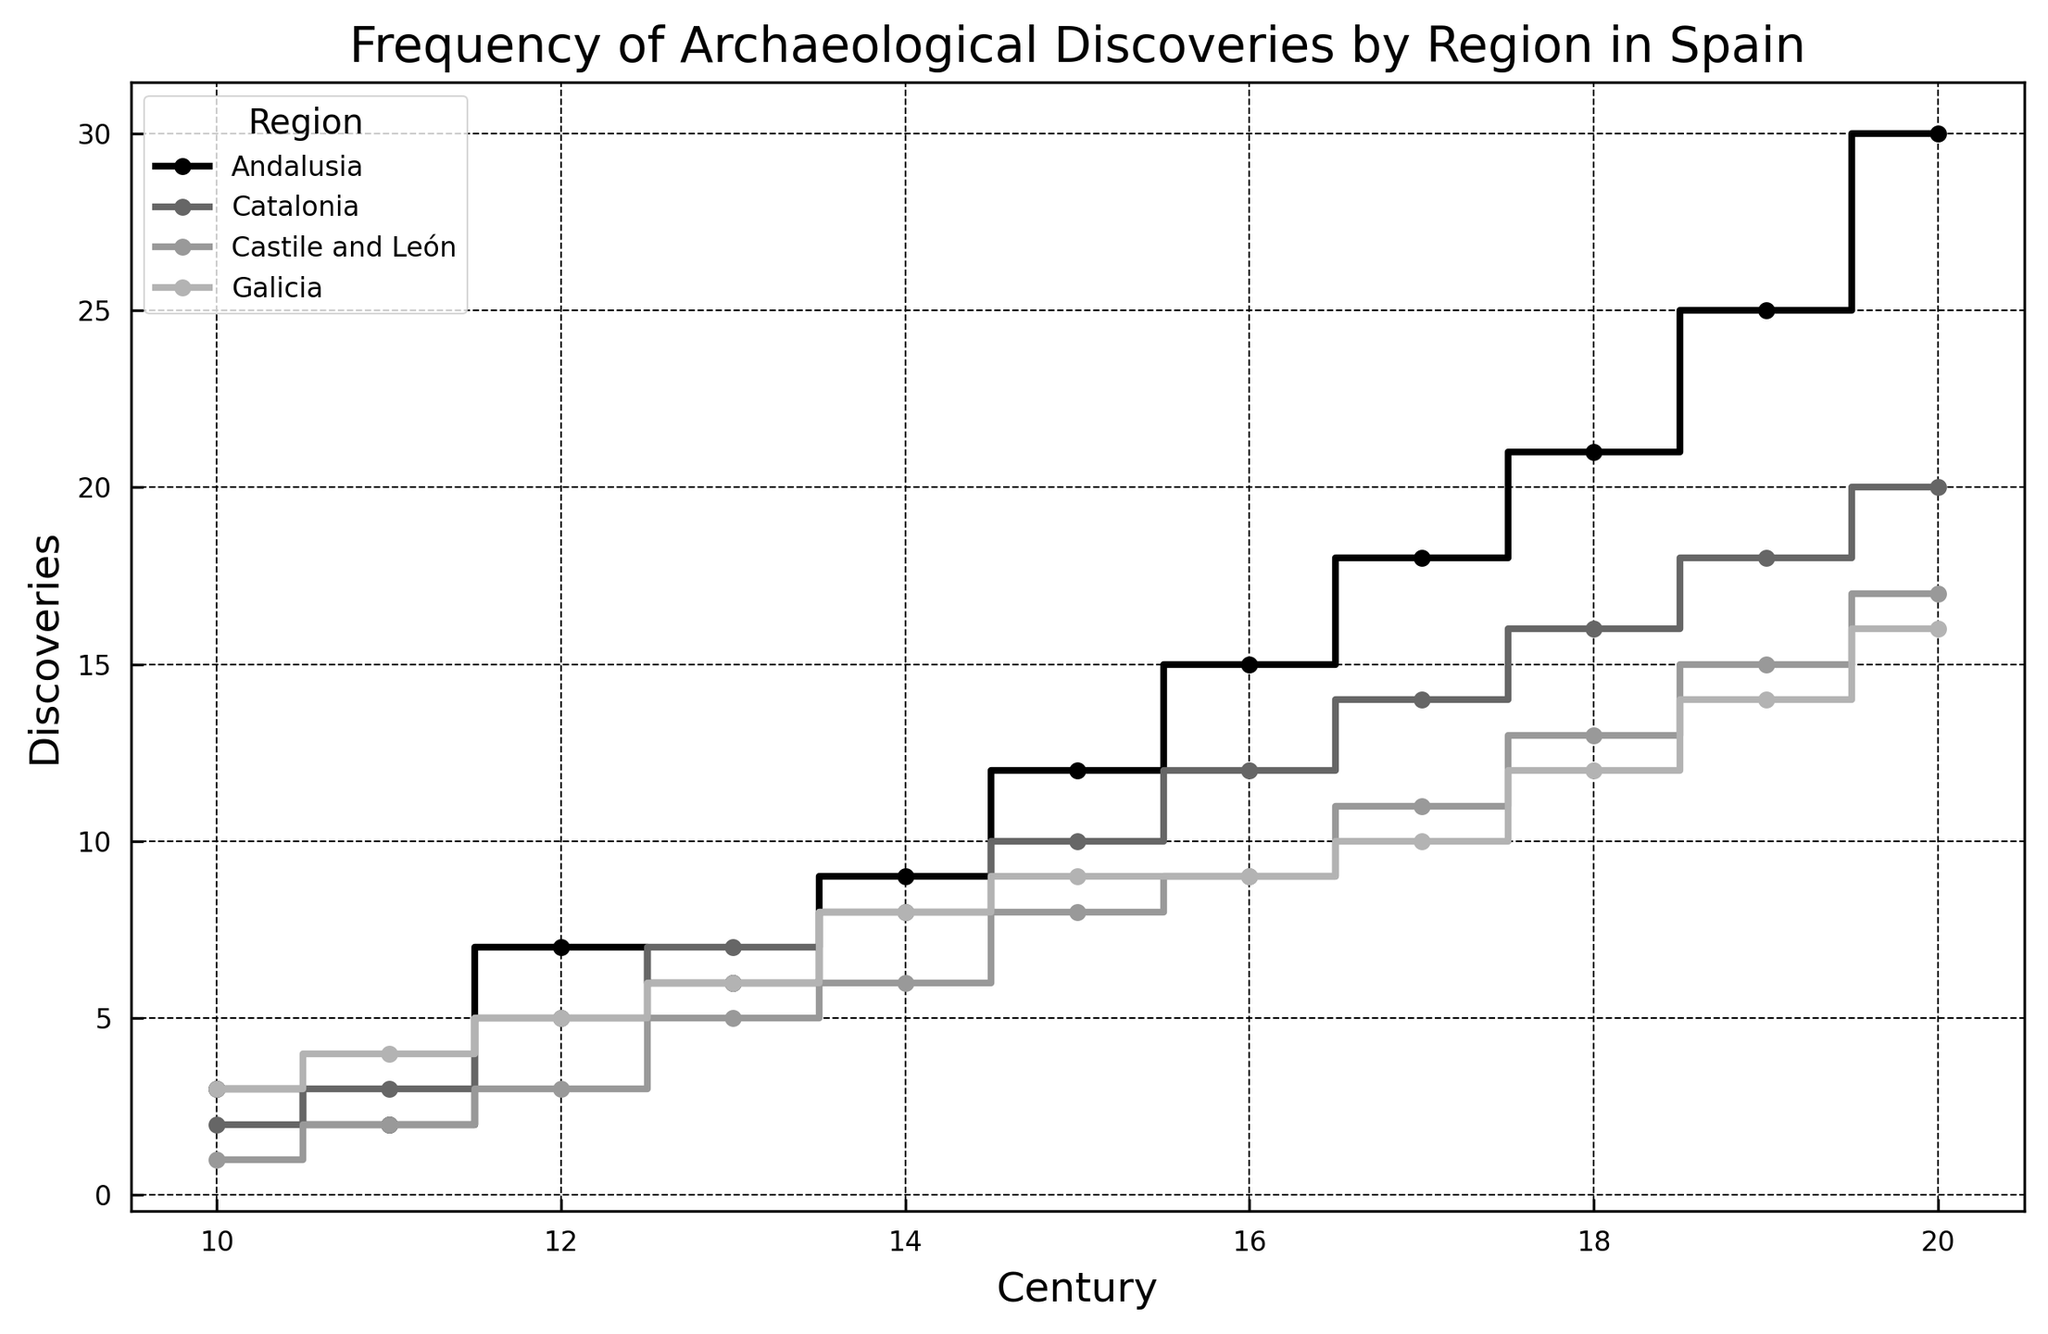Which region shows the most rapid increase in discoveries during the centuries? To determine which region shows the most rapid increase, observe the steepest slope and the highest and most frequent steps on the stairs plot. This rapid increase indicates more archaeological discoveries over time. Andalusia demonstrates the sharpest rise, especially from the 15th to the 20th centuries.
Answer: Andalusia Between the 15th and 16th centuries, which region had the highest increase in archaeological discoveries? Examine the data points between the 15th and 16th centuries for each region and compare the increments. Andalusia's discoveries went from 12 to 15, while Catalonia's increased from 10 to 12, Castile and León from 8 to 9, and Galicia from 9 to 9. Andalusia shows the highest increase.
Answer: Andalusia What is the average number of discoveries for Catalonia across all centuries? First, sum the discoveries for all centuries in Catalonia, then divide by the number of centuries (11). The total discoveries in Catalonia are 125. The average is calculated as 125 / 11.
Answer: 11.36 How does the number of discoveries in Galicia in the 20th century compare to those in Castile and León in the same century? Compare the discoveries in the 20th century for both Galicia and Castile and León. The discoveries are 16 for Galicia and 17 for Castile and León. Catalonia has one more discovery than Galicia.
Answer: Castile and León has more Which century saw the greatest difference between the number of discoveries in Andalusia and Castile and León? For each century, calculate the difference in discoveries between Andalusia and Castile and León, then identify the century with the greatest difference. The 20th century sees Andalusia with 30 discoveries and Castile and León with 17, making the greatest difference of 30 - 17.
Answer: 20th century Which region had the first significant rise in discoveries and in which century? Look for the first noticeable increase on the stairs plot for each region. Andalusia shows a significant rise in the 12th century, going from 2 to 7 discoveries.
Answer: Andalusia, 12th century What is the total number of discoveries in the 19th century across all regions? Sum the discoveries for all regions in the 19th century. Andalusia has 25, Catalonia 18, Castile and León 15, and Galicia 14. The total is 25 + 18 + 15 + 14.
Answer: 72 In the 18th century, which region had the least number of discoveries? Compare the discoveries in the 18th century for all regions. Andalusia had 21, Catalonia 16, Castile and León 13, and Galicia 12. Galicia has the least number of discoveries.
Answer: Galicia 